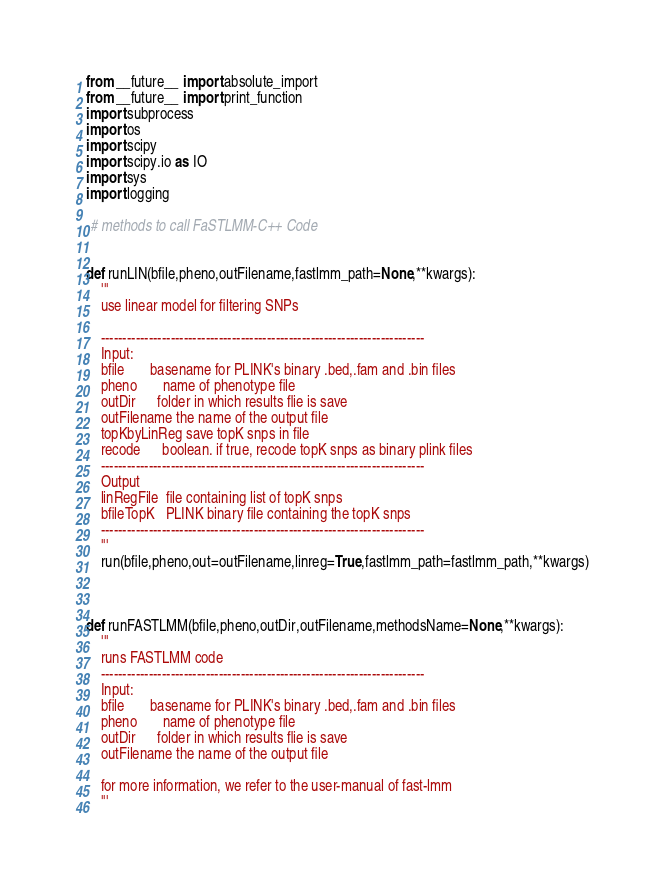Convert code to text. <code><loc_0><loc_0><loc_500><loc_500><_Python_>from __future__ import absolute_import
from __future__ import print_function
import subprocess 
import os 
import scipy
import scipy.io as IO
import sys
import logging

 # methods to call FaSTLMM-C++ Code


def runLIN(bfile,pheno,outFilename,fastlmm_path=None,**kwargs):
    '''    
    use linear model for filtering SNPs

    --------------------------------------------------------------------------
    Input:
    bfile       basename for PLINK's binary .bed,.fam and .bin files
    pheno       name of phenotype file
    outDir      folder in which results flie is save
    outFilename the name of the output file
    topKbyLinReg save topK snps in file
    recode      boolean. if true, recode topK snps as binary plink files
    --------------------------------------------------------------------------
    Output
    linRegFile  file containing list of topK snps
    bfileTopK   PLINK binary file containing the topK snps
    --------------------------------------------------------------------------
    '''
    run(bfile,pheno,out=outFilename,linreg=True,fastlmm_path=fastlmm_path,**kwargs)



def runFASTLMM(bfile,pheno,outDir,outFilename,methodsName=None,**kwargs):
    '''
    runs FASTLMM code
    --------------------------------------------------------------------------
    Input:
    bfile       basename for PLINK's binary .bed,.fam and .bin files
    pheno       name of phenotype file
    outDir      folder in which results flie is save
    outFilename the name of the output file
   
    for more information, we refer to the user-manual of fast-lmm
    '''</code> 